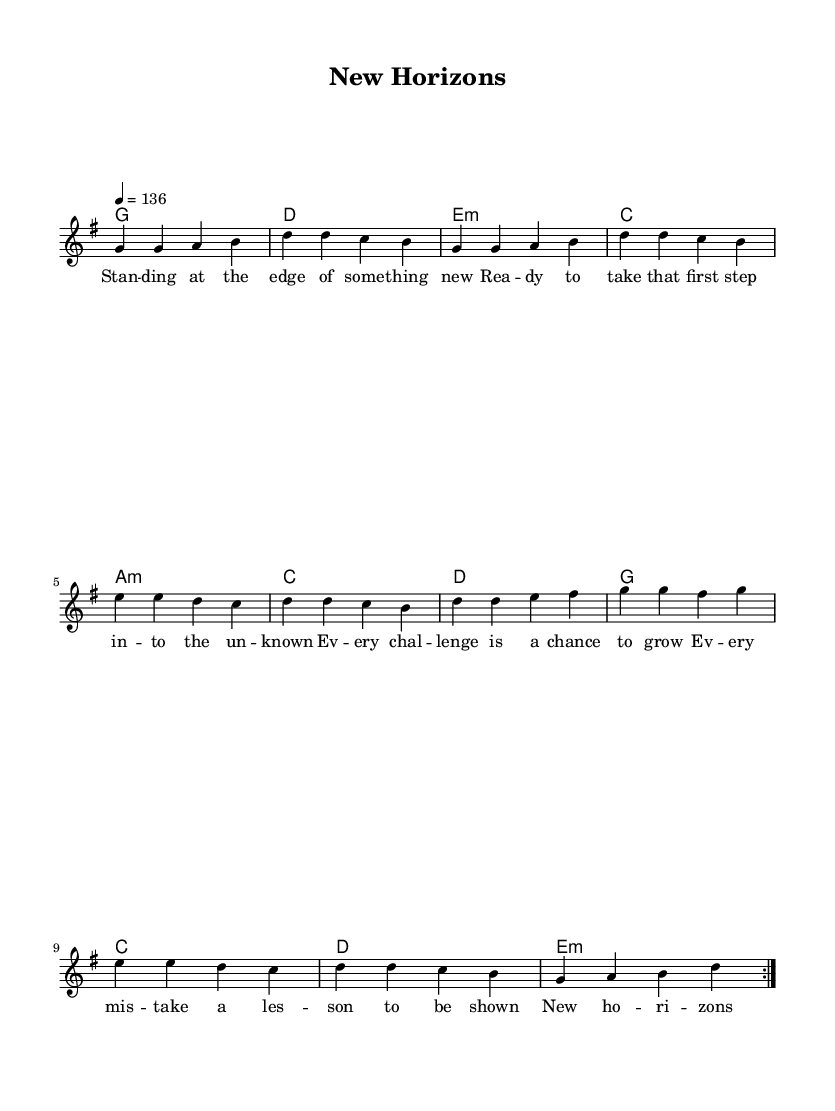What is the key signature of this music? The key signature is determined by the presence of sharps or flats at the beginning of the staff. In this music, there are no sharps or flats indicated, which means it is in G major.
Answer: G major What is the time signature of this music? The time signature is noted at the beginning of the music and indicates how many beats are in each measure. Here it is written as 4/4, meaning there are four beats per measure.
Answer: 4/4 What is the tempo marking of this music? The tempo is indicated under the global settings, which shows "4 = 136". This means that the quarter note (4) is set to a speed of 136 beats per minute.
Answer: 136 How many measures are in the repeated sections of the melody? The melody has a repeat indicated by "\repeat volta 2", and it consists of 10 measures in total that are repeated. Counting them, we have 10 measures in each repeat.
Answer: 10 What is the first chord in the harmonies? The first chord is the first element in the \harmonies section. It is indicated as "g1", which represents a G major chord played for a whole measure.
Answer: G What type of song does this sheet music represent? The content and structure of the lyrics and melody indicate a theme of new beginnings and learning, which is typical of an upbeat rock anthem. The style is characterized by positive energy and celebration.
Answer: Rock anthem How many lyrics lines are associated with the melody? By reviewing the verseWords section, there are six lines of lyrics that correspond to the melody provided. Each line represents a phrase of the song.
Answer: 6 